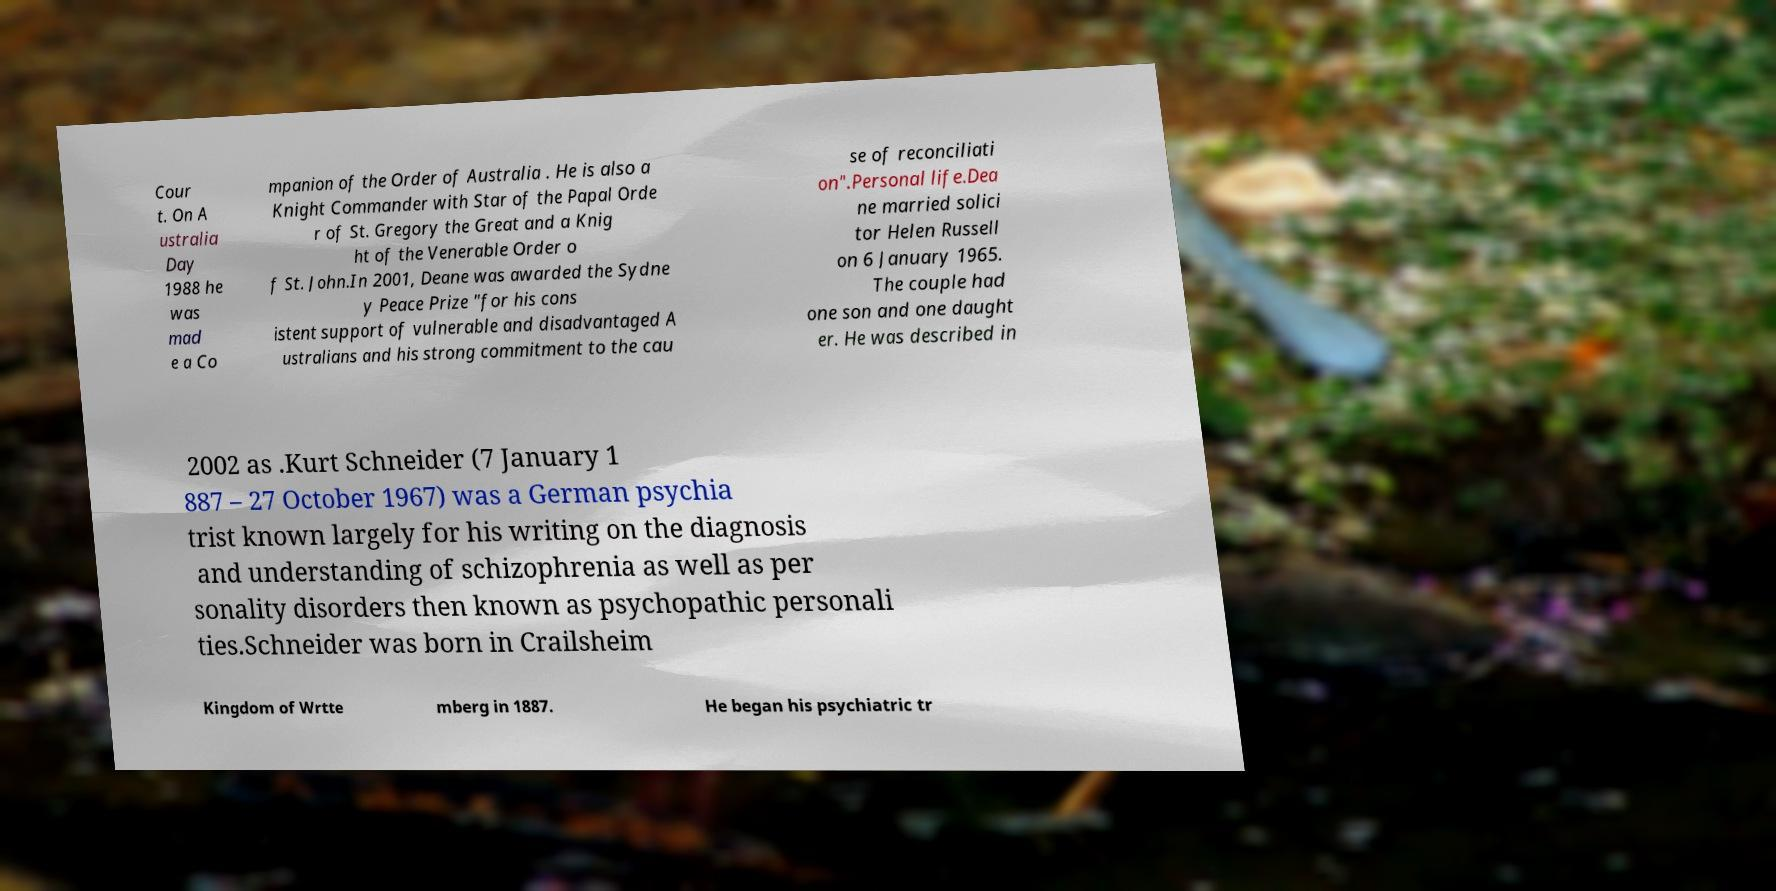There's text embedded in this image that I need extracted. Can you transcribe it verbatim? Cour t. On A ustralia Day 1988 he was mad e a Co mpanion of the Order of Australia . He is also a Knight Commander with Star of the Papal Orde r of St. Gregory the Great and a Knig ht of the Venerable Order o f St. John.In 2001, Deane was awarded the Sydne y Peace Prize "for his cons istent support of vulnerable and disadvantaged A ustralians and his strong commitment to the cau se of reconciliati on".Personal life.Dea ne married solici tor Helen Russell on 6 January 1965. The couple had one son and one daught er. He was described in 2002 as .Kurt Schneider (7 January 1 887 – 27 October 1967) was a German psychia trist known largely for his writing on the diagnosis and understanding of schizophrenia as well as per sonality disorders then known as psychopathic personali ties.Schneider was born in Crailsheim Kingdom of Wrtte mberg in 1887. He began his psychiatric tr 